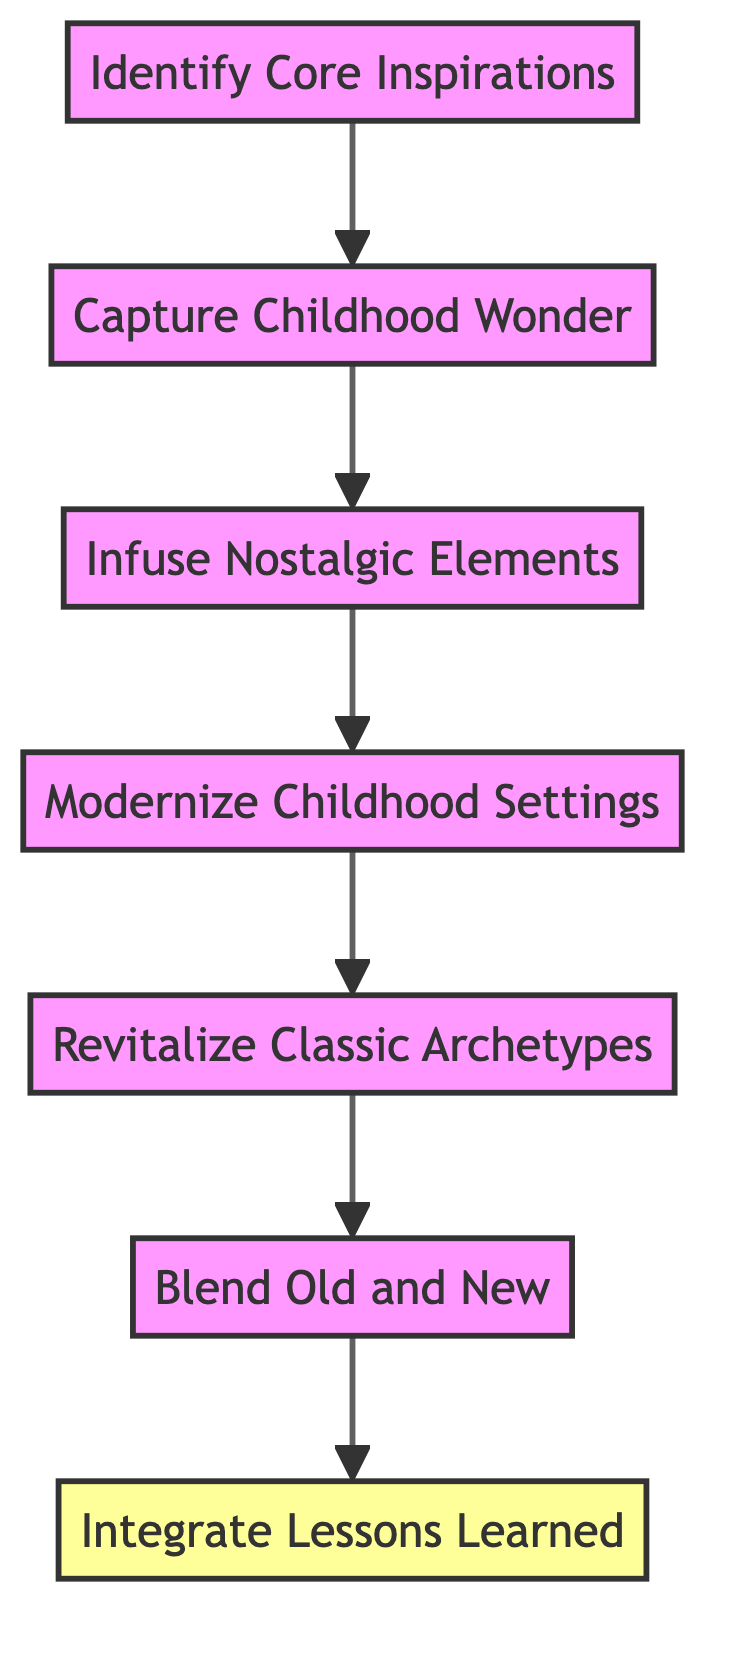What is the top node in the diagram? The top node is the final step in the flowchart, which represents the overarching goal of integrating various elements into the story. In this case, it is "Integrate Lessons Learned."
Answer: Integrate Lessons Learned How many nodes are there in the diagram? The counting involves each unique step represented in the diagram. There are a total of seven nodes, each corresponding to a specific action or concept.
Answer: 7 What is the relationship between "Capture Childhood Wonder" and "Infuse Nostalgic Elements"? The relationship is directional, with "Capture Childhood Wonder" leading into "Infuse Nostalgic Elements." This means that capturing the sense of wonder is a prerequisite for introducing nostalgic elements in the narrative.
Answer: Leads to Which node comes after "Modernize Childhood Settings"? After "Modernize Childhood Settings," the flowchart indicates that the next step is "Revitalize Classic Archetypes." This shows the progression in developing the storyline further by updating character archetypes.
Answer: Revitalize Classic Archetypes What happens after "Blend Old and New"? Following "Blend Old and New," the flowchart indicates that the next step is "Integrate Lessons Learned," which suggests that the blending of themes prepares the foundation for integrating lessons into the story.
Answer: Integrate Lessons Learned Which two nodes are directly connected to "Revitalize Classic Archetypes"? The nodes that are directly connected to "Revitalize Classic Archetypes" are "Modernize Childhood Settings" (leading into it) and "Blend Old and New" (leading out of it), establishing it as a key transition point in the narrative flow.
Answer: Modernize Childhood Settings and Blend Old and New What is the significance of the "Identify Core Inspirations" node? This node serves as the starting point in the flowchart, indicating that identifying significant childhood influences is the foundational step in weaving those inspirations into modern storylines.
Answer: Foundational step What does the flow from "Integrate Lessons Learned" signify? The flow from "Integrate Lessons Learned" signifies the culmination of the storytelling process, where all previous steps come together to impart the lessons gathered from childhood inspirations throughout the narrative.
Answer: Culmination of the process 